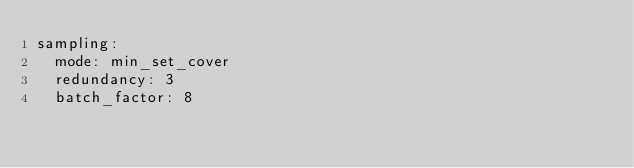Convert code to text. <code><loc_0><loc_0><loc_500><loc_500><_YAML_>sampling:
  mode: min_set_cover
  redundancy: 3
  batch_factor: 8</code> 